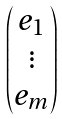Convert formula to latex. <formula><loc_0><loc_0><loc_500><loc_500>\begin{pmatrix} e _ { 1 } \\ \vdots \\ e _ { m } \end{pmatrix}</formula> 